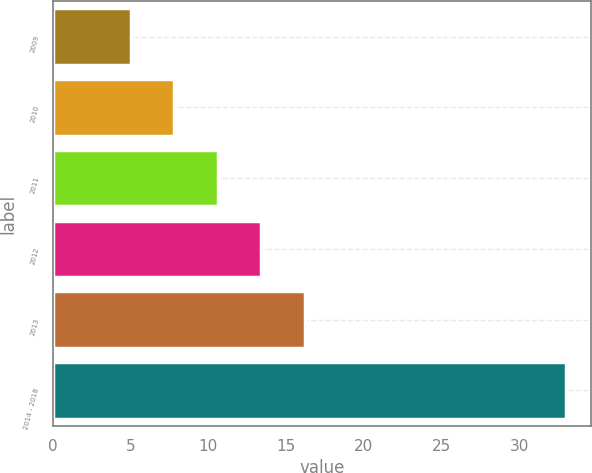<chart> <loc_0><loc_0><loc_500><loc_500><bar_chart><fcel>2009<fcel>2010<fcel>2011<fcel>2012<fcel>2013<fcel>2014 - 2018<nl><fcel>5<fcel>7.8<fcel>10.6<fcel>13.4<fcel>16.2<fcel>33<nl></chart> 